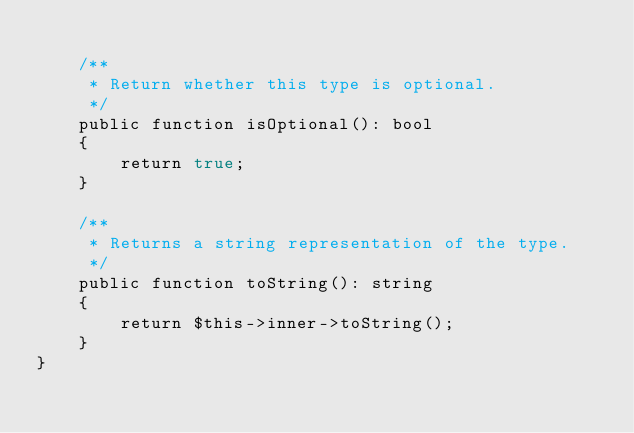<code> <loc_0><loc_0><loc_500><loc_500><_PHP_>
    /**
     * Return whether this type is optional.
     */
    public function isOptional(): bool
    {
        return true;
    }

    /**
     * Returns a string representation of the type.
     */
    public function toString(): string
    {
        return $this->inner->toString();
    }
}
</code> 